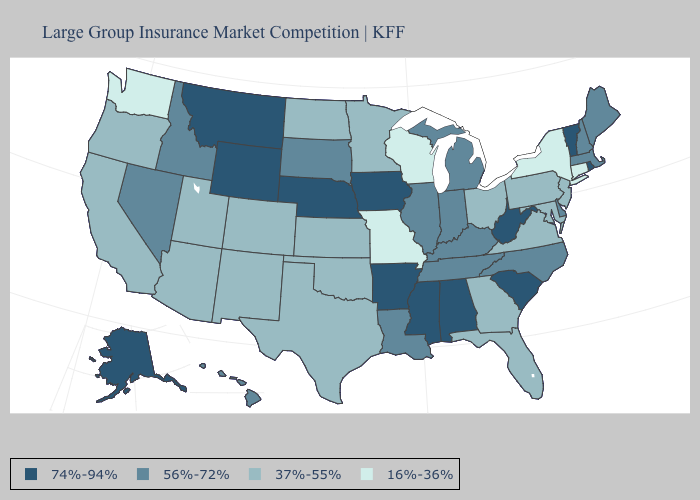What is the lowest value in states that border Maryland?
Write a very short answer. 37%-55%. Does Hawaii have the same value as Massachusetts?
Keep it brief. Yes. Among the states that border Virginia , which have the lowest value?
Give a very brief answer. Maryland. Does Massachusetts have the highest value in the USA?
Concise answer only. No. What is the value of South Dakota?
Quick response, please. 56%-72%. Which states have the lowest value in the West?
Short answer required. Washington. Does South Carolina have the highest value in the South?
Quick response, please. Yes. Name the states that have a value in the range 56%-72%?
Be succinct. Delaware, Hawaii, Idaho, Illinois, Indiana, Kentucky, Louisiana, Maine, Massachusetts, Michigan, Nevada, New Hampshire, North Carolina, South Dakota, Tennessee. Does the first symbol in the legend represent the smallest category?
Answer briefly. No. Name the states that have a value in the range 16%-36%?
Short answer required. Connecticut, Missouri, New York, Washington, Wisconsin. What is the highest value in states that border Louisiana?
Keep it brief. 74%-94%. What is the highest value in the USA?
Concise answer only. 74%-94%. What is the lowest value in the Northeast?
Quick response, please. 16%-36%. 